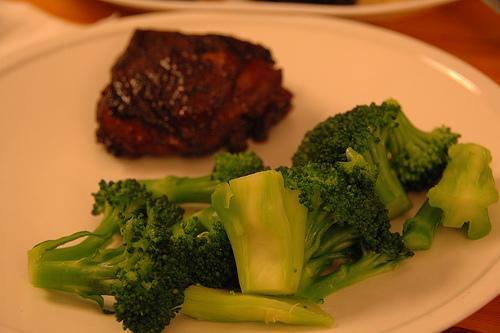Describe the appearance of the meat in the image. The meat is brown with a charbroiled top. What color is the plate? The plate is white. Give a detailed description of the meal on the plate. The meal consists of multiple green broccoli florets and stalks, and a piece of charbroiled brown meat on a white plate. Analyze the overall sentiment or mood of the image. The image has a neutral sentiment representing a healthy and appetizing meal. What is the most dominant color of the broccoli? The broccoli is mostly green. How many green pieces on stems are there in the image? There are 10 green pieces on stems. What is the condition of the broccoli on the plate? The broccoli is cleaned. Identify the main components of the meal in the image. The main components are broccoli and a piece of meat. Estimate the number of broccoli florets and stalks on the plate. There are around ten pieces of broccoli on the plate. What is the main type of food on the plate? Broccoli and a piece of meat Which type of food is on the plate with the green vegetables? Meat Identify the interaction between the meat and broccoli. The meat and broccoli are touching each other on the plate. Can you identify if it's a piece of pork on the plate? One of the captions is about a piece of beef with green leafy vegetables, so suggesting it's pork is misleading. Select the object that is out of view but can be inferred: table, chair, spoon, knife. Table What is the overall color of the broccoli in the image? Green Recognize the activity taking place in the image. No activity, just a still image of meat and broccoli on a plate What is the color of the meat?  Brown State a phrase to describe the color and type of vegetable on the plate. Green leafy vegetables - broccoli Are the broccoli florets facing upwards on the plate? One of the captions mentions an upside-down broccoli floret, so suggesting that they all are facing upwards is misleading. Locate the largest serving of broccoli on the plate. Green broccoli floret on plate Which of the following objects are a part of this image: utensils, broccoli, steak, tomatoes?  broccoli and steak What color is the plate the food is placed on? White What is the overall impression of the image: healthy, tasty, overcooked, or elegant? Healthy Write a short summary of the image. A plate contains green broccoli and a piece of meat on a table. What type of vegetables are on the plate with the meat? Broccoli Is there a table with a bottom left corner in the image? The image has a top right corner of the table but no mention of the bottom left corner, so asking for its presence is misleading. Describe the main ingredients present in the image. Green broccoli and a piece of meat Where is the reflection of light found on the plate? On the edge of the white plate How many pieces of broccoli are on the plate? Ten Identify an upturned broccoli floret in the image. Upside down broccoli floret Is the broccoli cooked or raw? Cannot determine from the information provided. Is the plate pink and square-shaped? The plate was described as round and white, suggesting it to be pink and square-shaped is misleading. Do you see only three pieces of broccoli on the plate? One of the captions mentions ten pieces of brocoli on the plate, so suggesting only three is misleading. Is the broccoli on the plate red? The instructions mention the broccoli multiple times as green, so suggesting it to be red is misleading. Describe the contents of the plate. The plate has pieces of green broccoli and a piece of meat. 